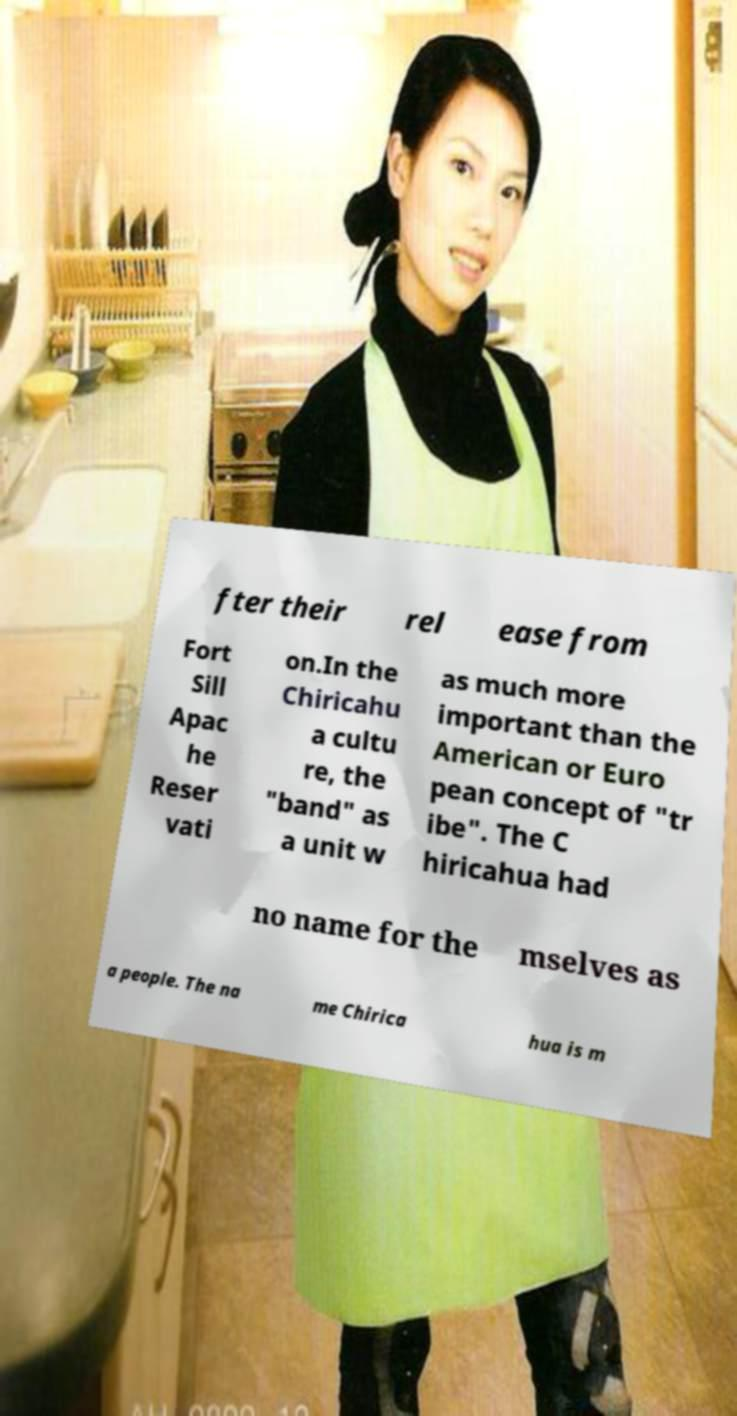For documentation purposes, I need the text within this image transcribed. Could you provide that? fter their rel ease from Fort Sill Apac he Reser vati on.In the Chiricahu a cultu re, the "band" as a unit w as much more important than the American or Euro pean concept of "tr ibe". The C hiricahua had no name for the mselves as a people. The na me Chirica hua is m 